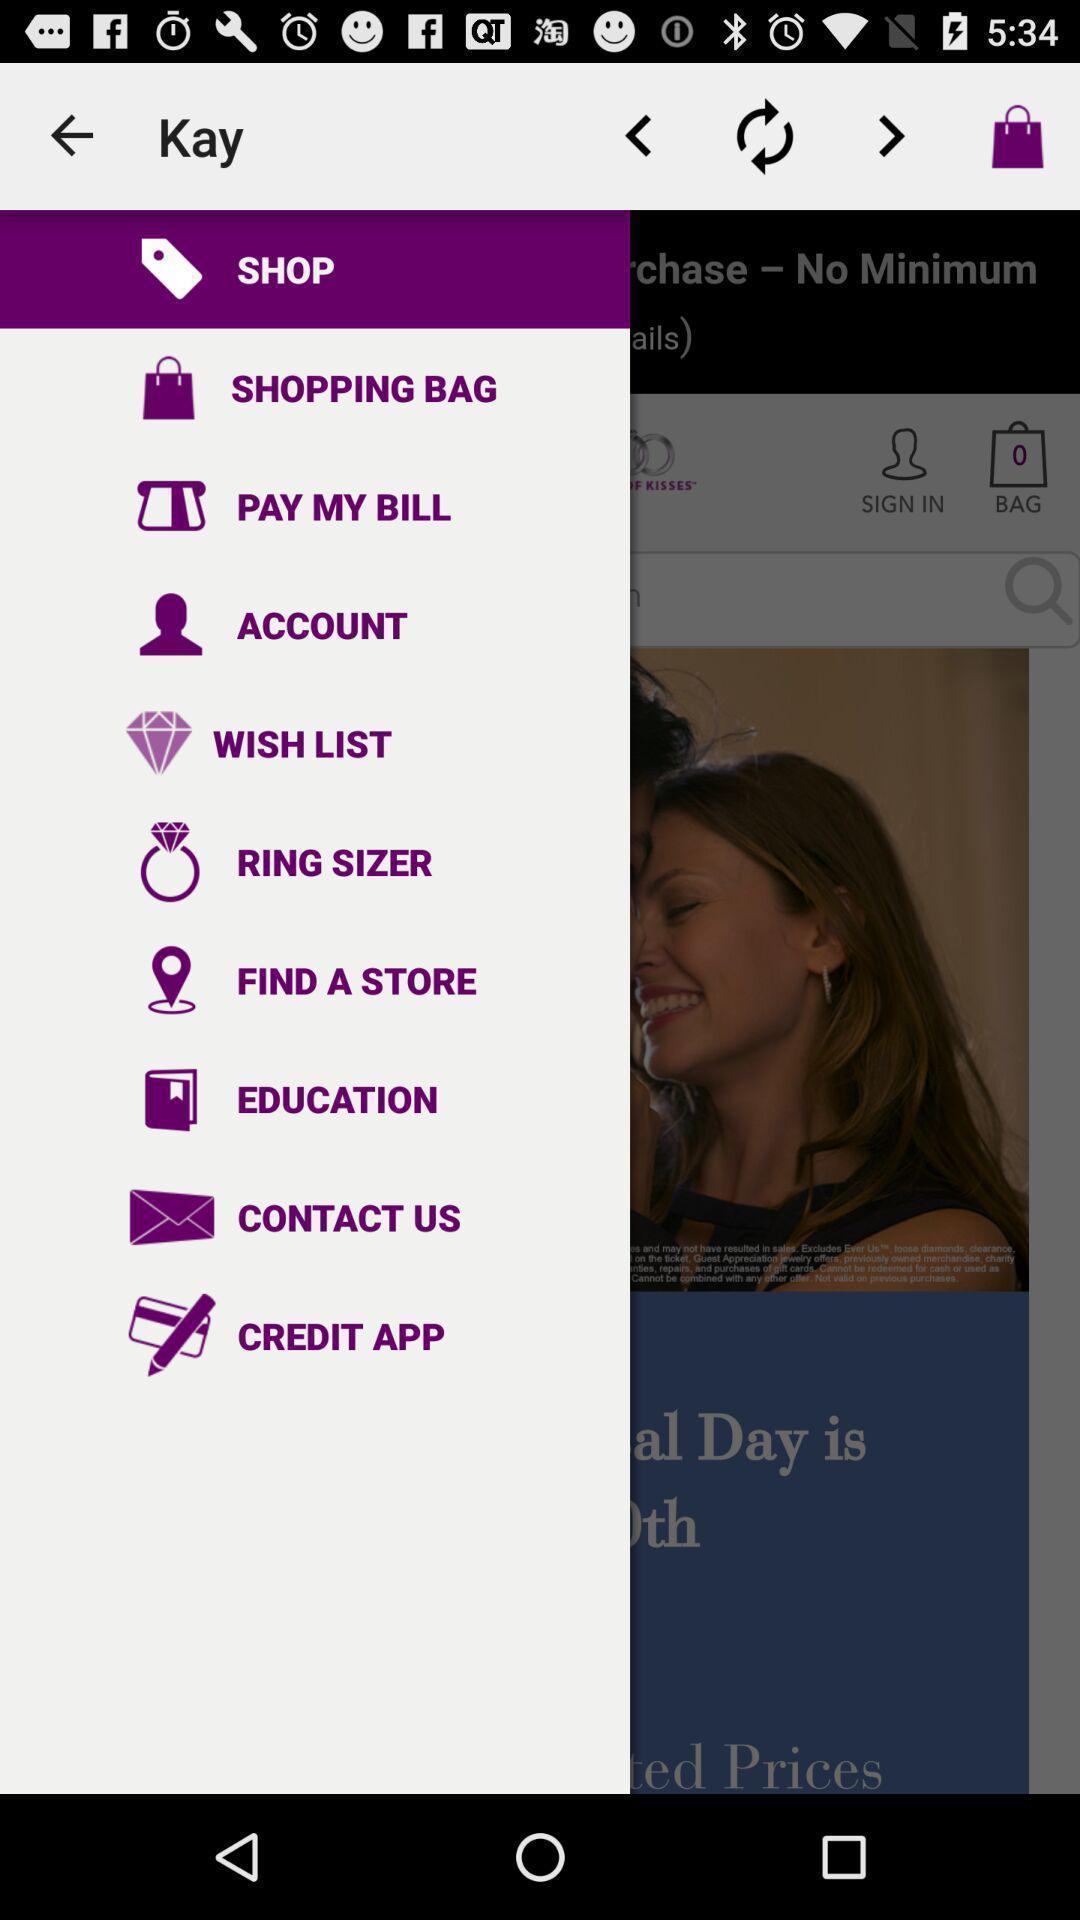Provide a description of this screenshot. Screen shows different options in a shopping app. 